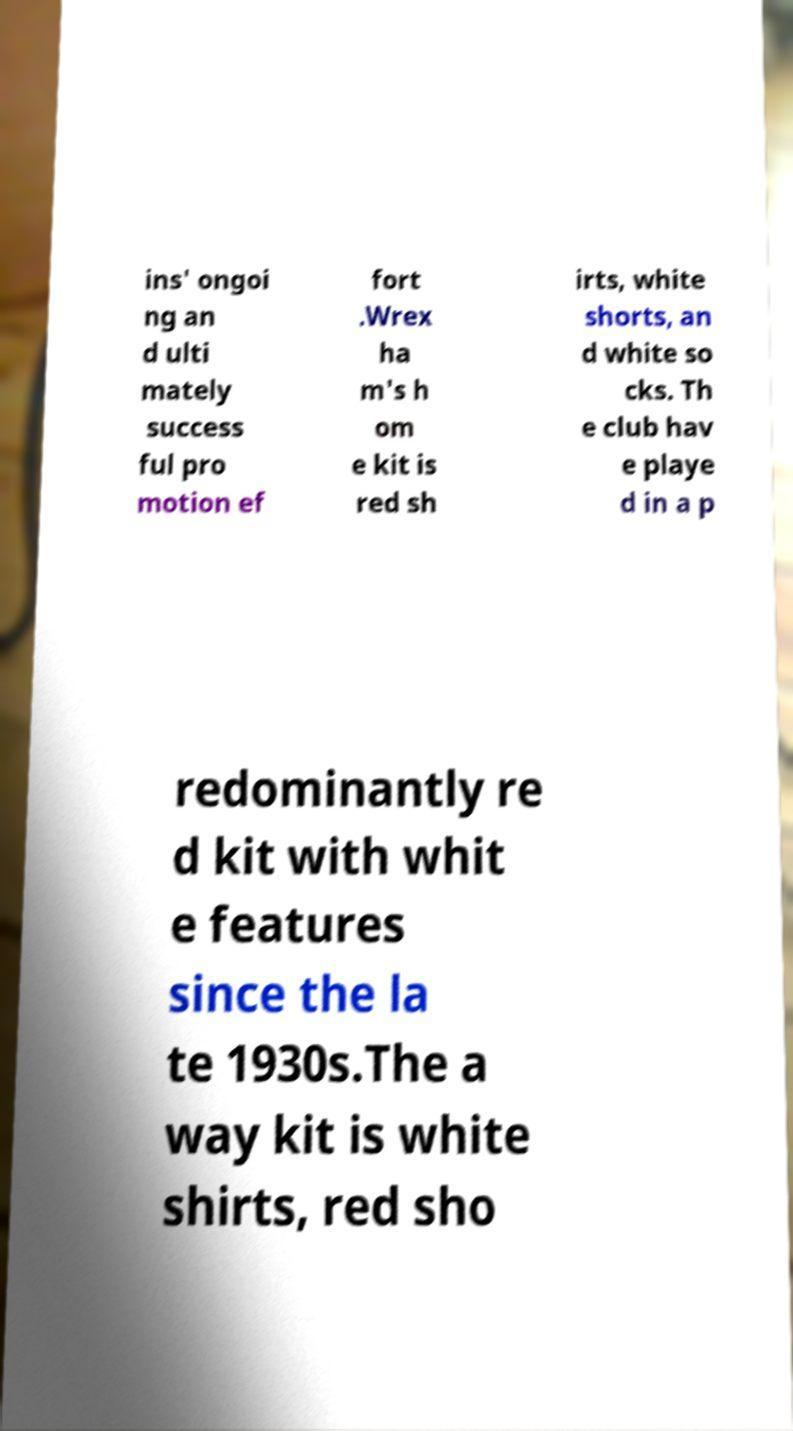Please read and relay the text visible in this image. What does it say? ins' ongoi ng an d ulti mately success ful pro motion ef fort .Wrex ha m's h om e kit is red sh irts, white shorts, an d white so cks. Th e club hav e playe d in a p redominantly re d kit with whit e features since the la te 1930s.The a way kit is white shirts, red sho 